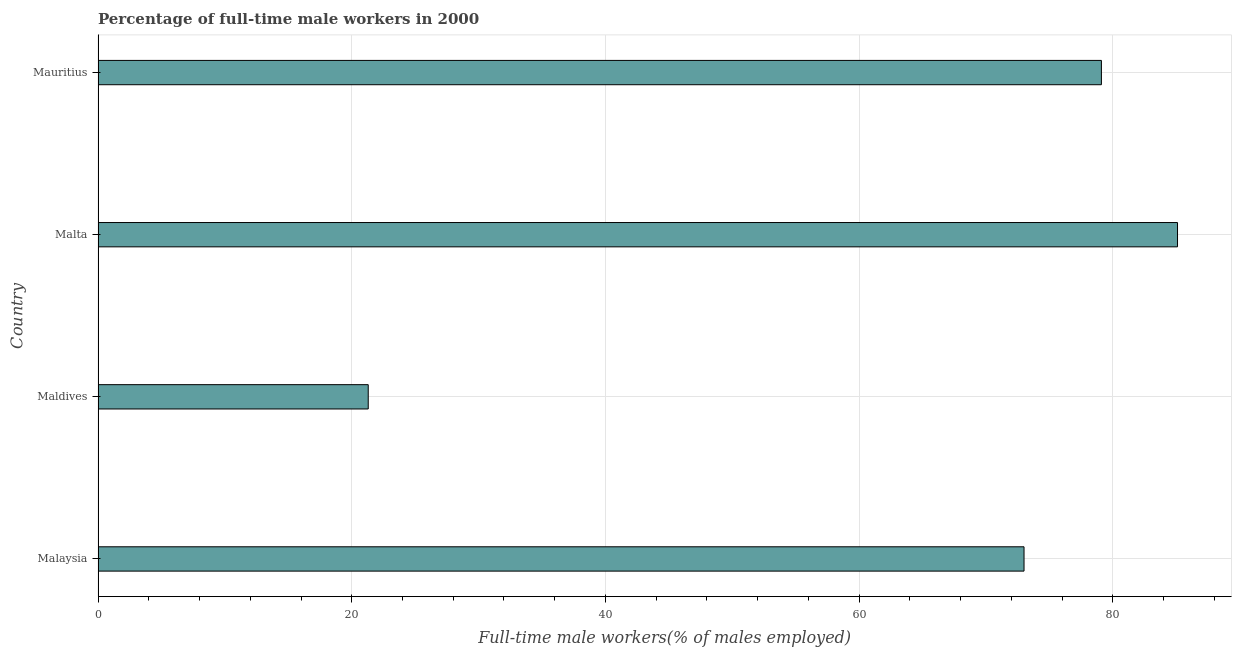Does the graph contain any zero values?
Make the answer very short. No. Does the graph contain grids?
Offer a terse response. Yes. What is the title of the graph?
Your answer should be compact. Percentage of full-time male workers in 2000. What is the label or title of the X-axis?
Ensure brevity in your answer.  Full-time male workers(% of males employed). What is the label or title of the Y-axis?
Your response must be concise. Country. What is the percentage of full-time male workers in Mauritius?
Keep it short and to the point. 79.1. Across all countries, what is the maximum percentage of full-time male workers?
Keep it short and to the point. 85.1. Across all countries, what is the minimum percentage of full-time male workers?
Your response must be concise. 21.3. In which country was the percentage of full-time male workers maximum?
Your answer should be compact. Malta. In which country was the percentage of full-time male workers minimum?
Keep it short and to the point. Maldives. What is the sum of the percentage of full-time male workers?
Offer a very short reply. 258.5. What is the difference between the percentage of full-time male workers in Malta and Mauritius?
Make the answer very short. 6. What is the average percentage of full-time male workers per country?
Make the answer very short. 64.62. What is the median percentage of full-time male workers?
Make the answer very short. 76.05. What is the ratio of the percentage of full-time male workers in Malaysia to that in Malta?
Give a very brief answer. 0.86. Is the percentage of full-time male workers in Malaysia less than that in Malta?
Make the answer very short. Yes. Is the difference between the percentage of full-time male workers in Malaysia and Mauritius greater than the difference between any two countries?
Provide a succinct answer. No. What is the difference between the highest and the second highest percentage of full-time male workers?
Offer a very short reply. 6. Is the sum of the percentage of full-time male workers in Malaysia and Malta greater than the maximum percentage of full-time male workers across all countries?
Your answer should be compact. Yes. What is the difference between the highest and the lowest percentage of full-time male workers?
Make the answer very short. 63.8. In how many countries, is the percentage of full-time male workers greater than the average percentage of full-time male workers taken over all countries?
Your response must be concise. 3. How many countries are there in the graph?
Offer a terse response. 4. Are the values on the major ticks of X-axis written in scientific E-notation?
Offer a very short reply. No. What is the Full-time male workers(% of males employed) in Maldives?
Provide a short and direct response. 21.3. What is the Full-time male workers(% of males employed) in Malta?
Ensure brevity in your answer.  85.1. What is the Full-time male workers(% of males employed) in Mauritius?
Provide a short and direct response. 79.1. What is the difference between the Full-time male workers(% of males employed) in Malaysia and Maldives?
Your answer should be compact. 51.7. What is the difference between the Full-time male workers(% of males employed) in Malaysia and Malta?
Your answer should be very brief. -12.1. What is the difference between the Full-time male workers(% of males employed) in Maldives and Malta?
Your response must be concise. -63.8. What is the difference between the Full-time male workers(% of males employed) in Maldives and Mauritius?
Ensure brevity in your answer.  -57.8. What is the ratio of the Full-time male workers(% of males employed) in Malaysia to that in Maldives?
Keep it short and to the point. 3.43. What is the ratio of the Full-time male workers(% of males employed) in Malaysia to that in Malta?
Offer a very short reply. 0.86. What is the ratio of the Full-time male workers(% of males employed) in Malaysia to that in Mauritius?
Your response must be concise. 0.92. What is the ratio of the Full-time male workers(% of males employed) in Maldives to that in Malta?
Provide a short and direct response. 0.25. What is the ratio of the Full-time male workers(% of males employed) in Maldives to that in Mauritius?
Your answer should be compact. 0.27. What is the ratio of the Full-time male workers(% of males employed) in Malta to that in Mauritius?
Offer a terse response. 1.08. 